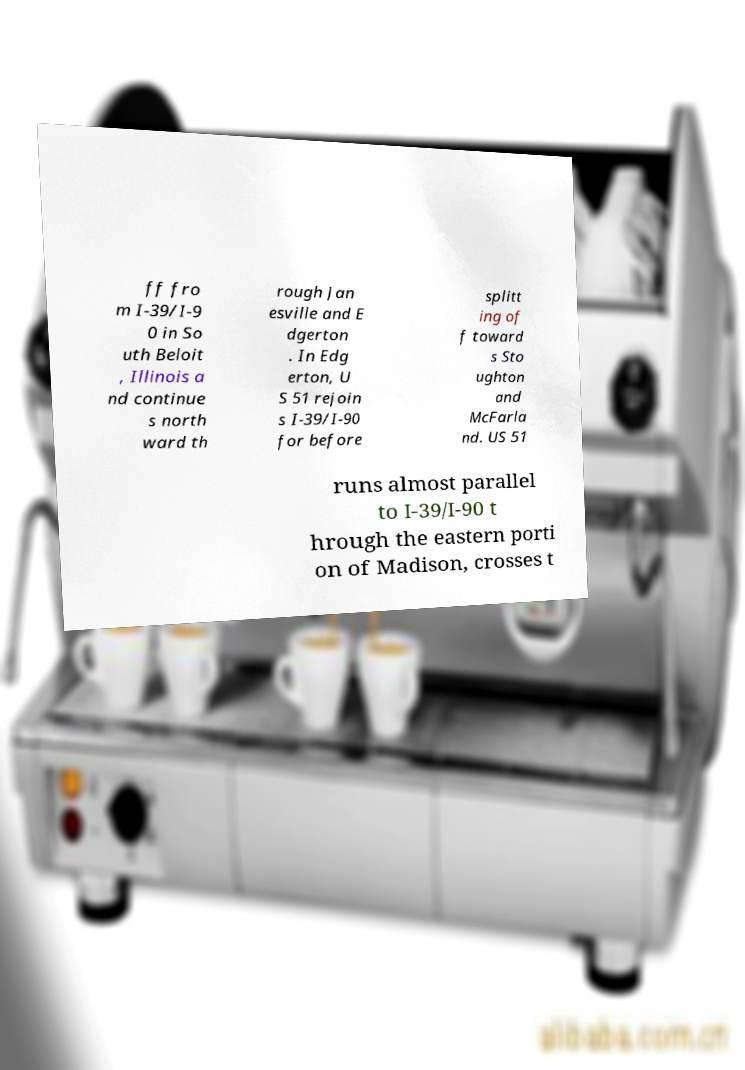What messages or text are displayed in this image? I need them in a readable, typed format. ff fro m I-39/I-9 0 in So uth Beloit , Illinois a nd continue s north ward th rough Jan esville and E dgerton . In Edg erton, U S 51 rejoin s I-39/I-90 for before splitt ing of f toward s Sto ughton and McFarla nd. US 51 runs almost parallel to I-39/I-90 t hrough the eastern porti on of Madison, crosses t 